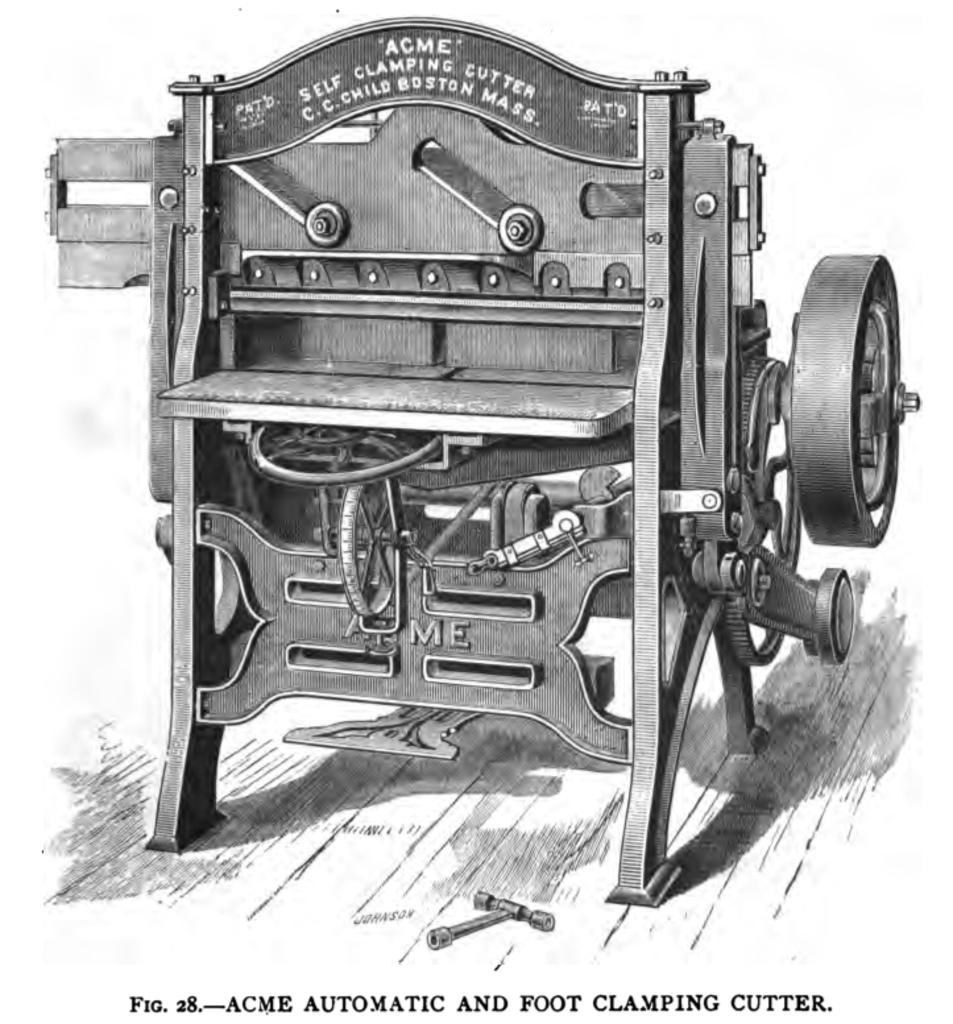How would you summarize this image in a sentence or two? Black and white picture. A picture of a machine. Bottom of the image there is a watermark. 